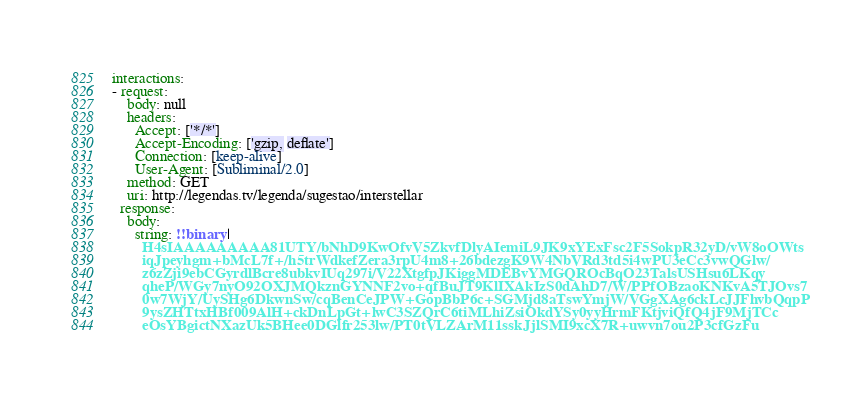Convert code to text. <code><loc_0><loc_0><loc_500><loc_500><_YAML_>interactions:
- request:
    body: null
    headers:
      Accept: ['*/*']
      Accept-Encoding: ['gzip, deflate']
      Connection: [keep-alive]
      User-Agent: [Subliminal/2.0]
    method: GET
    uri: http://legendas.tv/legenda/sugestao/interstellar
  response:
    body:
      string: !!binary |
        H4sIAAAAAAAAA81UTY/bNhD9KwOfvV5ZkvfDlyAIemiL9JK9xYExFsc2F5SokpR32yD/vW8oOWts
        iqJpeyhgm+bMcL7f+/h5trWdkefZera3rpU4m8+26bdezgK9W4NbVRd3td5i4wPU3eCc3vwQGlw/
        z6zZji9ebCGyrdlBcre8ubkvIUq297i/V22XtgfpJKiggMDEBvYMGQROcBqO23TalsUSHsu6LKqy
        qheP/WGy7nyO92OXJMQkznGYNNF2vo+qfBuJT9KlIXAkIzS0dAhD7/W/PPfOBzaoKNKvA5TJOvs7
        0w7WjY/UySHg6DkwnSw/cqBenCeJPW+GopBbP6c+SGMjd8aTswYmjW/VGgXAg6ckLcJJFhvbQqpP
        9ysZHTtxHBf009AlH+ckDnLpGt+lwC3SZQrC6tiMLhiZsiOkdYSy0yyHrmFKtjviQfQ4jF9MjTCc
        eOsYBgictNXazUk5BHee0DGlfr253lw/PT0tVLZArM11sskJjlSMI9xcX7R+uwvn7ou2P3cfGzFu</code> 